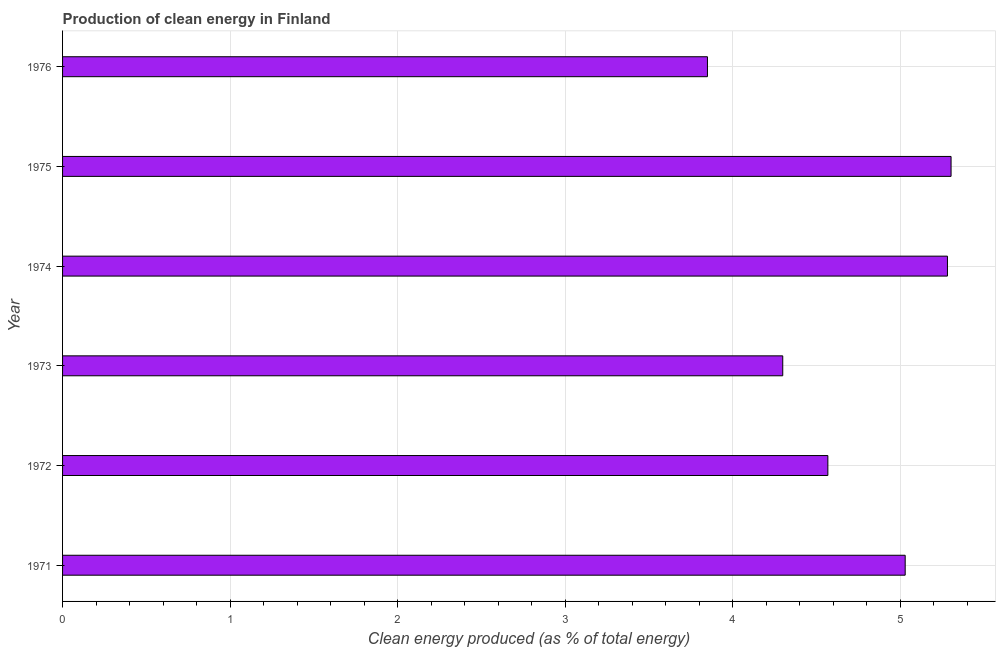Does the graph contain any zero values?
Your response must be concise. No. What is the title of the graph?
Provide a succinct answer. Production of clean energy in Finland. What is the label or title of the X-axis?
Your answer should be very brief. Clean energy produced (as % of total energy). What is the label or title of the Y-axis?
Your response must be concise. Year. What is the production of clean energy in 1973?
Offer a terse response. 4.3. Across all years, what is the maximum production of clean energy?
Keep it short and to the point. 5.3. Across all years, what is the minimum production of clean energy?
Offer a very short reply. 3.85. In which year was the production of clean energy maximum?
Provide a succinct answer. 1975. In which year was the production of clean energy minimum?
Ensure brevity in your answer.  1976. What is the sum of the production of clean energy?
Give a very brief answer. 28.34. What is the difference between the production of clean energy in 1972 and 1973?
Provide a short and direct response. 0.27. What is the average production of clean energy per year?
Provide a short and direct response. 4.72. What is the median production of clean energy?
Your response must be concise. 4.8. In how many years, is the production of clean energy greater than 3 %?
Provide a short and direct response. 6. What is the ratio of the production of clean energy in 1971 to that in 1973?
Your answer should be very brief. 1.17. What is the difference between the highest and the second highest production of clean energy?
Make the answer very short. 0.02. Is the sum of the production of clean energy in 1971 and 1973 greater than the maximum production of clean energy across all years?
Your answer should be compact. Yes. What is the difference between the highest and the lowest production of clean energy?
Ensure brevity in your answer.  1.45. In how many years, is the production of clean energy greater than the average production of clean energy taken over all years?
Keep it short and to the point. 3. How many bars are there?
Your answer should be compact. 6. Are all the bars in the graph horizontal?
Your response must be concise. Yes. What is the Clean energy produced (as % of total energy) in 1971?
Your answer should be very brief. 5.03. What is the Clean energy produced (as % of total energy) of 1972?
Ensure brevity in your answer.  4.57. What is the Clean energy produced (as % of total energy) in 1973?
Ensure brevity in your answer.  4.3. What is the Clean energy produced (as % of total energy) of 1974?
Give a very brief answer. 5.28. What is the Clean energy produced (as % of total energy) in 1975?
Your response must be concise. 5.3. What is the Clean energy produced (as % of total energy) in 1976?
Make the answer very short. 3.85. What is the difference between the Clean energy produced (as % of total energy) in 1971 and 1972?
Your response must be concise. 0.46. What is the difference between the Clean energy produced (as % of total energy) in 1971 and 1973?
Offer a terse response. 0.73. What is the difference between the Clean energy produced (as % of total energy) in 1971 and 1974?
Make the answer very short. -0.25. What is the difference between the Clean energy produced (as % of total energy) in 1971 and 1975?
Your answer should be very brief. -0.27. What is the difference between the Clean energy produced (as % of total energy) in 1971 and 1976?
Give a very brief answer. 1.18. What is the difference between the Clean energy produced (as % of total energy) in 1972 and 1973?
Offer a very short reply. 0.27. What is the difference between the Clean energy produced (as % of total energy) in 1972 and 1974?
Your answer should be compact. -0.71. What is the difference between the Clean energy produced (as % of total energy) in 1972 and 1975?
Your answer should be compact. -0.74. What is the difference between the Clean energy produced (as % of total energy) in 1972 and 1976?
Your answer should be compact. 0.72. What is the difference between the Clean energy produced (as % of total energy) in 1973 and 1974?
Make the answer very short. -0.98. What is the difference between the Clean energy produced (as % of total energy) in 1973 and 1975?
Give a very brief answer. -1. What is the difference between the Clean energy produced (as % of total energy) in 1973 and 1976?
Give a very brief answer. 0.45. What is the difference between the Clean energy produced (as % of total energy) in 1974 and 1975?
Offer a terse response. -0.02. What is the difference between the Clean energy produced (as % of total energy) in 1974 and 1976?
Your response must be concise. 1.43. What is the difference between the Clean energy produced (as % of total energy) in 1975 and 1976?
Your response must be concise. 1.45. What is the ratio of the Clean energy produced (as % of total energy) in 1971 to that in 1972?
Offer a terse response. 1.1. What is the ratio of the Clean energy produced (as % of total energy) in 1971 to that in 1973?
Offer a very short reply. 1.17. What is the ratio of the Clean energy produced (as % of total energy) in 1971 to that in 1974?
Provide a succinct answer. 0.95. What is the ratio of the Clean energy produced (as % of total energy) in 1971 to that in 1975?
Keep it short and to the point. 0.95. What is the ratio of the Clean energy produced (as % of total energy) in 1971 to that in 1976?
Your answer should be very brief. 1.31. What is the ratio of the Clean energy produced (as % of total energy) in 1972 to that in 1973?
Your answer should be very brief. 1.06. What is the ratio of the Clean energy produced (as % of total energy) in 1972 to that in 1974?
Provide a succinct answer. 0.86. What is the ratio of the Clean energy produced (as % of total energy) in 1972 to that in 1975?
Provide a short and direct response. 0.86. What is the ratio of the Clean energy produced (as % of total energy) in 1972 to that in 1976?
Your answer should be very brief. 1.19. What is the ratio of the Clean energy produced (as % of total energy) in 1973 to that in 1974?
Make the answer very short. 0.81. What is the ratio of the Clean energy produced (as % of total energy) in 1973 to that in 1975?
Your response must be concise. 0.81. What is the ratio of the Clean energy produced (as % of total energy) in 1973 to that in 1976?
Ensure brevity in your answer.  1.12. What is the ratio of the Clean energy produced (as % of total energy) in 1974 to that in 1975?
Keep it short and to the point. 1. What is the ratio of the Clean energy produced (as % of total energy) in 1974 to that in 1976?
Make the answer very short. 1.37. What is the ratio of the Clean energy produced (as % of total energy) in 1975 to that in 1976?
Give a very brief answer. 1.38. 